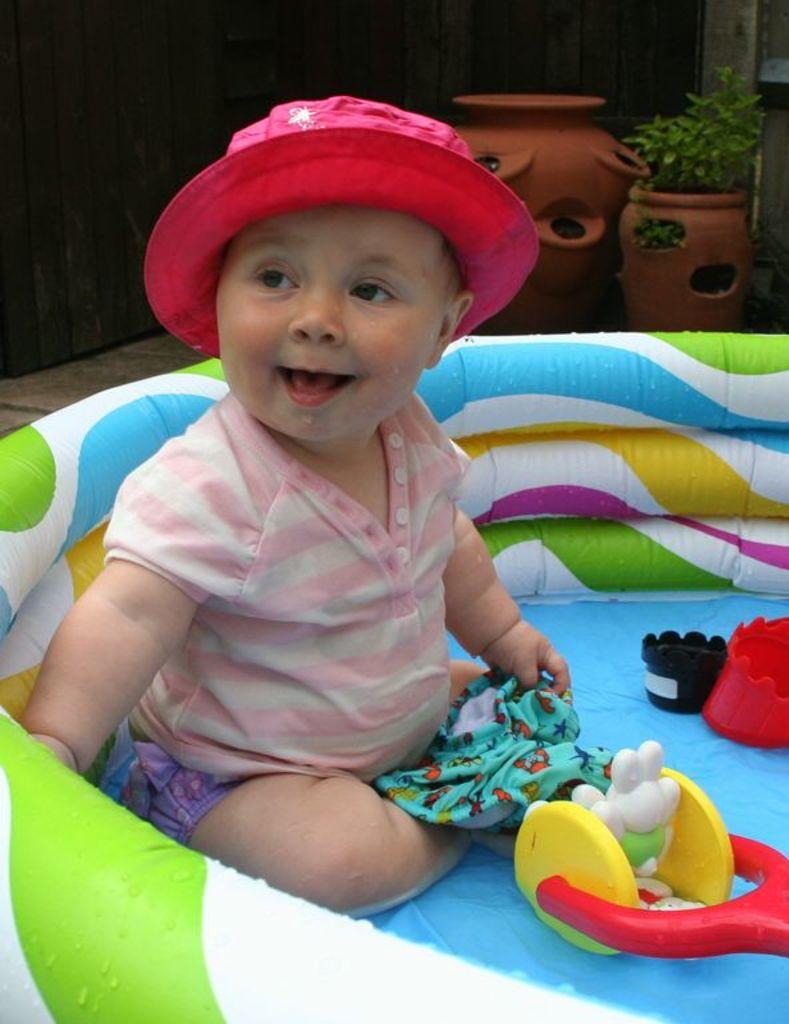What is the main subject of the image? There is a baby in the image. What is the baby sitting in? The baby is sitting in an object. What is the baby wearing? The baby is wearing a hat. What is the baby holding? The baby is holding an object. What can be seen in the background of the image? There are toys, pots, and other objects in the background of the image. What type of crime is being committed in the image? There is no crime being committed in the image; it features a baby sitting and holding an object. How does the baby plan to join the other objects in the background? The baby is not planning to join any objects in the background; they are simply sitting and holding an object. 